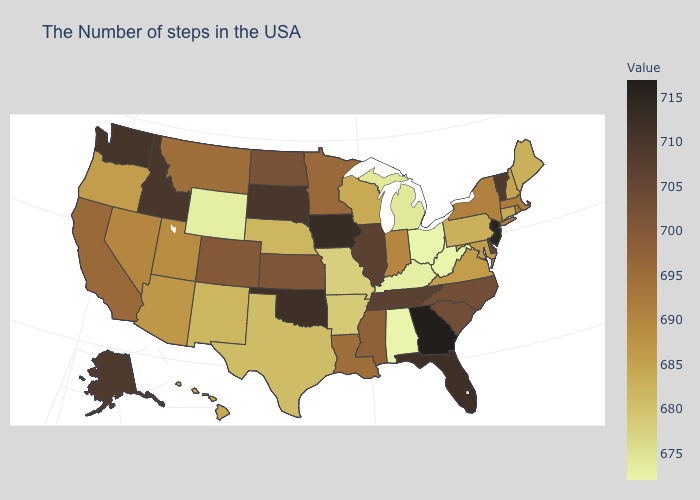Does Illinois have the lowest value in the MidWest?
Write a very short answer. No. Among the states that border Virginia , which have the highest value?
Quick response, please. Tennessee. Among the states that border Tennessee , does Arkansas have the lowest value?
Quick response, please. No. Is the legend a continuous bar?
Short answer required. Yes. Does the map have missing data?
Give a very brief answer. No. Is the legend a continuous bar?
Answer briefly. Yes. Among the states that border Washington , does Idaho have the lowest value?
Concise answer only. No. 